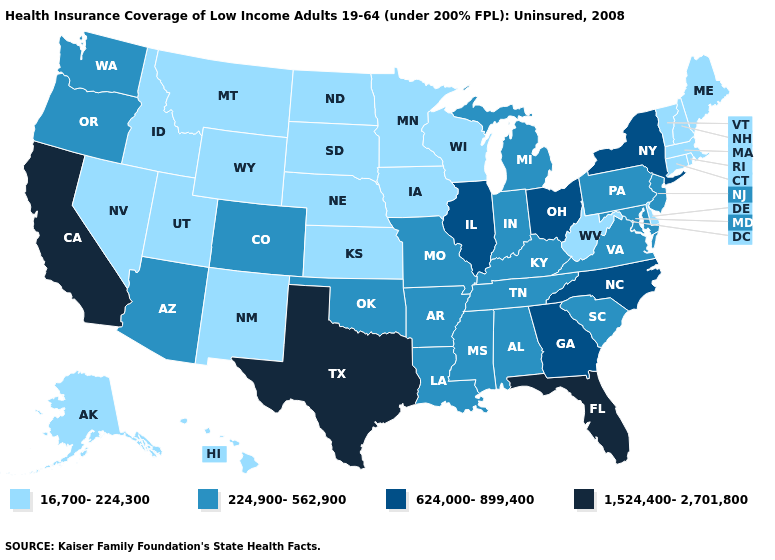What is the value of Washington?
Answer briefly. 224,900-562,900. Name the states that have a value in the range 624,000-899,400?
Keep it brief. Georgia, Illinois, New York, North Carolina, Ohio. Does Tennessee have a higher value than Rhode Island?
Answer briefly. Yes. What is the value of Alaska?
Concise answer only. 16,700-224,300. What is the value of Tennessee?
Quick response, please. 224,900-562,900. What is the value of North Dakota?
Write a very short answer. 16,700-224,300. Which states have the highest value in the USA?
Write a very short answer. California, Florida, Texas. Which states have the lowest value in the West?
Give a very brief answer. Alaska, Hawaii, Idaho, Montana, Nevada, New Mexico, Utah, Wyoming. What is the highest value in states that border Indiana?
Write a very short answer. 624,000-899,400. Does Florida have the highest value in the USA?
Keep it brief. Yes. Does Kansas have a higher value than Nevada?
Concise answer only. No. What is the value of New York?
Keep it brief. 624,000-899,400. Does Texas have the highest value in the South?
Keep it brief. Yes. What is the highest value in states that border West Virginia?
Be succinct. 624,000-899,400. Does New Hampshire have a higher value than West Virginia?
Concise answer only. No. 